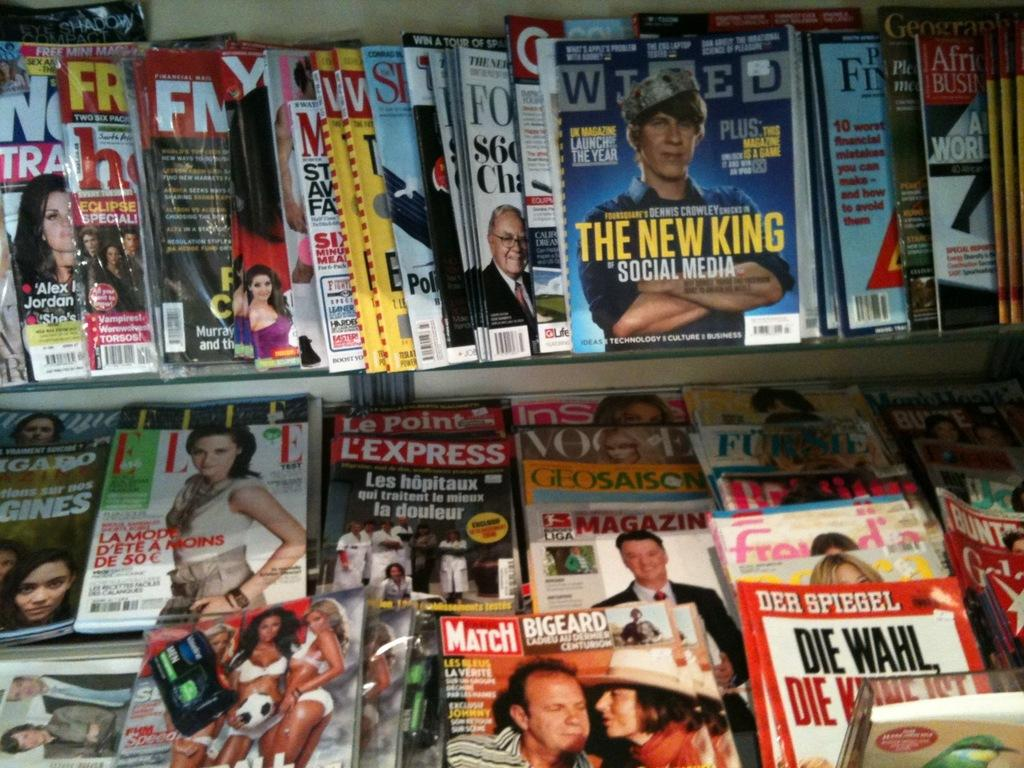<image>
Summarize the visual content of the image. Lots of magazines such as Ellie, Express and Vogue. 